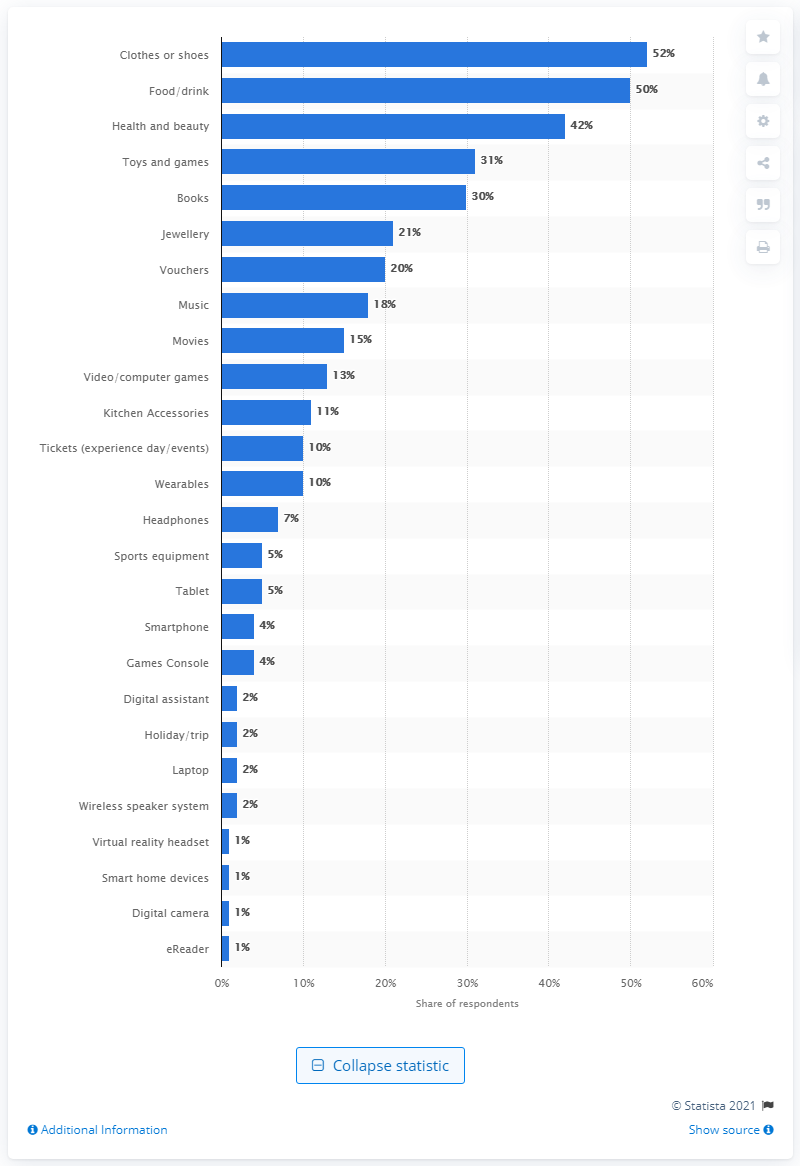Draw attention to some important aspects in this diagram. According to data, eReaders, digital cameras, smart home devices, and virtual reality headsets collectively accounted for approximately 1% of consumer purchases. According to the survey, 42% of respondents reported having a budget of 100-400 British pounds. 